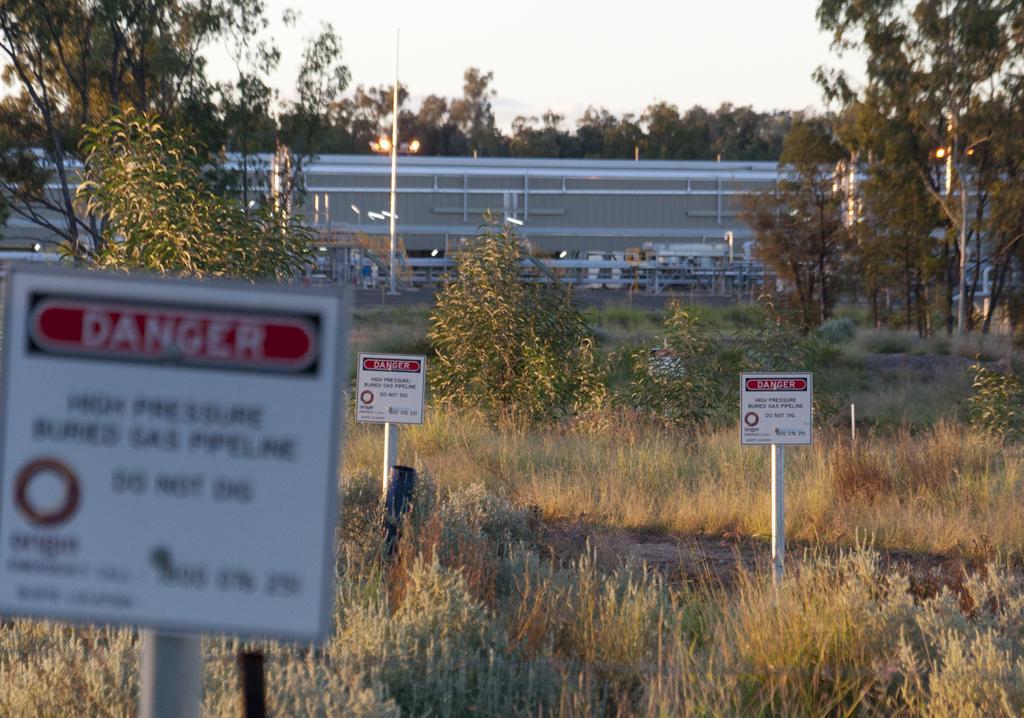How would you summarize this image in a sentence or two? In this picture we can observe white color caution boards fixed to the poles. There is some dried grass on the ground. In the background there are trees. We can observe a sky. 